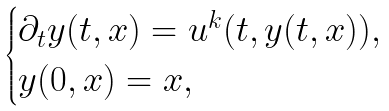<formula> <loc_0><loc_0><loc_500><loc_500>\begin{cases} \partial _ { t } y ( t , x ) = u ^ { k } ( t , y ( t , x ) ) , \\ y ( 0 , x ) = x , \end{cases}</formula> 